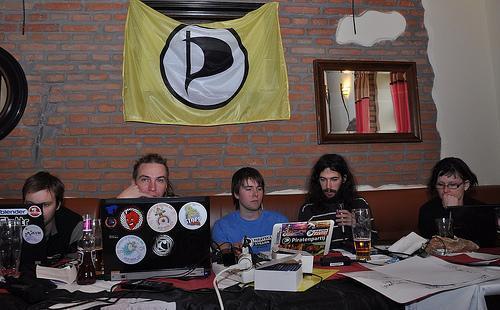How many stickers are on the laptop?
Give a very brief answer. 6. How many peole wears blue t-shirts?
Give a very brief answer. 1. 